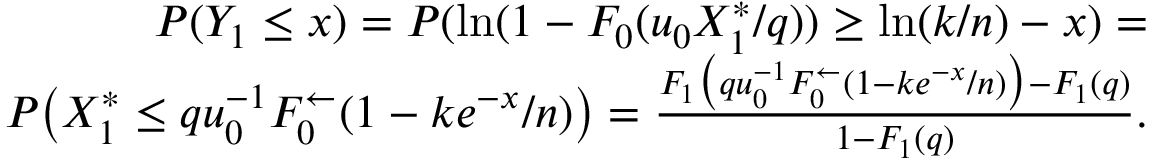<formula> <loc_0><loc_0><loc_500><loc_500>\begin{array} { r } { P ( Y _ { 1 } \leq x ) = P ( \ln ( 1 - F _ { 0 } ( u _ { 0 } X _ { 1 } ^ { \ast } / q ) ) \geq \ln ( k / n ) - x ) = } \\ { P \left ( X _ { 1 } ^ { \ast } \leq q u _ { 0 } ^ { - 1 } F _ { 0 } ^ { \leftarrow } ( 1 - k e ^ { - x } / n ) \right ) = \frac { F _ { 1 } \left ( q u _ { 0 } ^ { - 1 } F _ { 0 } ^ { \leftarrow } ( 1 - k e ^ { - x } / n ) \right ) - F _ { 1 } ( q ) } { 1 - F _ { 1 } ( q ) } . } \end{array}</formula> 